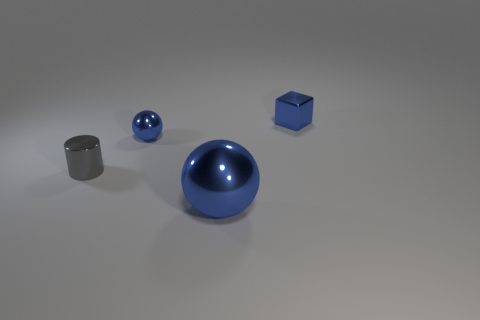What is the tiny gray thing made of? The tiny gray item in the image appears to be made of metal, likely steel or aluminum, given its industrial gray color and the way it reflects light similarly to the other objects, which suggests they might be part of a set designed to showcase different geometric shapes. 